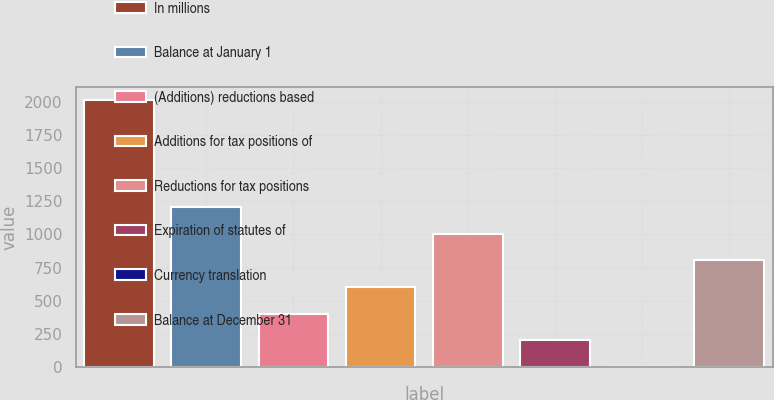Convert chart. <chart><loc_0><loc_0><loc_500><loc_500><bar_chart><fcel>In millions<fcel>Balance at January 1<fcel>(Additions) reductions based<fcel>Additions for tax positions of<fcel>Reductions for tax positions<fcel>Expiration of statutes of<fcel>Currency translation<fcel>Balance at December 31<nl><fcel>2013<fcel>1208.2<fcel>403.4<fcel>604.6<fcel>1007<fcel>202.2<fcel>1<fcel>805.8<nl></chart> 